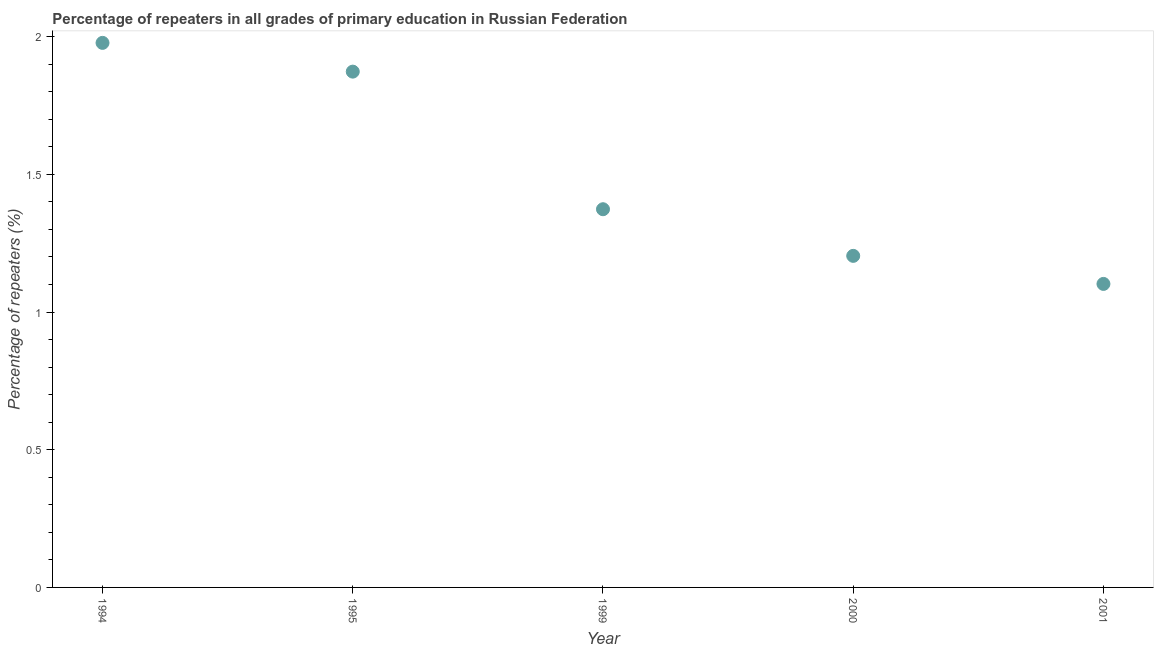What is the percentage of repeaters in primary education in 2001?
Provide a short and direct response. 1.1. Across all years, what is the maximum percentage of repeaters in primary education?
Provide a succinct answer. 1.98. Across all years, what is the minimum percentage of repeaters in primary education?
Your response must be concise. 1.1. In which year was the percentage of repeaters in primary education minimum?
Offer a very short reply. 2001. What is the sum of the percentage of repeaters in primary education?
Provide a succinct answer. 7.53. What is the difference between the percentage of repeaters in primary education in 1995 and 2001?
Make the answer very short. 0.77. What is the average percentage of repeaters in primary education per year?
Provide a short and direct response. 1.51. What is the median percentage of repeaters in primary education?
Your answer should be compact. 1.37. What is the ratio of the percentage of repeaters in primary education in 1994 to that in 1999?
Ensure brevity in your answer.  1.44. What is the difference between the highest and the second highest percentage of repeaters in primary education?
Keep it short and to the point. 0.1. Is the sum of the percentage of repeaters in primary education in 1995 and 2000 greater than the maximum percentage of repeaters in primary education across all years?
Make the answer very short. Yes. What is the difference between the highest and the lowest percentage of repeaters in primary education?
Give a very brief answer. 0.88. How many years are there in the graph?
Your answer should be very brief. 5. What is the difference between two consecutive major ticks on the Y-axis?
Make the answer very short. 0.5. Does the graph contain grids?
Make the answer very short. No. What is the title of the graph?
Give a very brief answer. Percentage of repeaters in all grades of primary education in Russian Federation. What is the label or title of the Y-axis?
Your answer should be compact. Percentage of repeaters (%). What is the Percentage of repeaters (%) in 1994?
Make the answer very short. 1.98. What is the Percentage of repeaters (%) in 1995?
Make the answer very short. 1.87. What is the Percentage of repeaters (%) in 1999?
Your answer should be compact. 1.37. What is the Percentage of repeaters (%) in 2000?
Ensure brevity in your answer.  1.2. What is the Percentage of repeaters (%) in 2001?
Your answer should be very brief. 1.1. What is the difference between the Percentage of repeaters (%) in 1994 and 1995?
Your answer should be very brief. 0.1. What is the difference between the Percentage of repeaters (%) in 1994 and 1999?
Your answer should be compact. 0.6. What is the difference between the Percentage of repeaters (%) in 1994 and 2000?
Provide a short and direct response. 0.77. What is the difference between the Percentage of repeaters (%) in 1994 and 2001?
Your answer should be very brief. 0.88. What is the difference between the Percentage of repeaters (%) in 1995 and 1999?
Keep it short and to the point. 0.5. What is the difference between the Percentage of repeaters (%) in 1995 and 2000?
Your answer should be compact. 0.67. What is the difference between the Percentage of repeaters (%) in 1995 and 2001?
Make the answer very short. 0.77. What is the difference between the Percentage of repeaters (%) in 1999 and 2000?
Your answer should be very brief. 0.17. What is the difference between the Percentage of repeaters (%) in 1999 and 2001?
Offer a terse response. 0.27. What is the difference between the Percentage of repeaters (%) in 2000 and 2001?
Keep it short and to the point. 0.1. What is the ratio of the Percentage of repeaters (%) in 1994 to that in 1995?
Offer a very short reply. 1.06. What is the ratio of the Percentage of repeaters (%) in 1994 to that in 1999?
Give a very brief answer. 1.44. What is the ratio of the Percentage of repeaters (%) in 1994 to that in 2000?
Offer a very short reply. 1.64. What is the ratio of the Percentage of repeaters (%) in 1994 to that in 2001?
Your response must be concise. 1.79. What is the ratio of the Percentage of repeaters (%) in 1995 to that in 1999?
Provide a succinct answer. 1.36. What is the ratio of the Percentage of repeaters (%) in 1995 to that in 2000?
Make the answer very short. 1.56. What is the ratio of the Percentage of repeaters (%) in 1995 to that in 2001?
Ensure brevity in your answer.  1.7. What is the ratio of the Percentage of repeaters (%) in 1999 to that in 2000?
Your response must be concise. 1.14. What is the ratio of the Percentage of repeaters (%) in 1999 to that in 2001?
Provide a short and direct response. 1.25. What is the ratio of the Percentage of repeaters (%) in 2000 to that in 2001?
Ensure brevity in your answer.  1.09. 